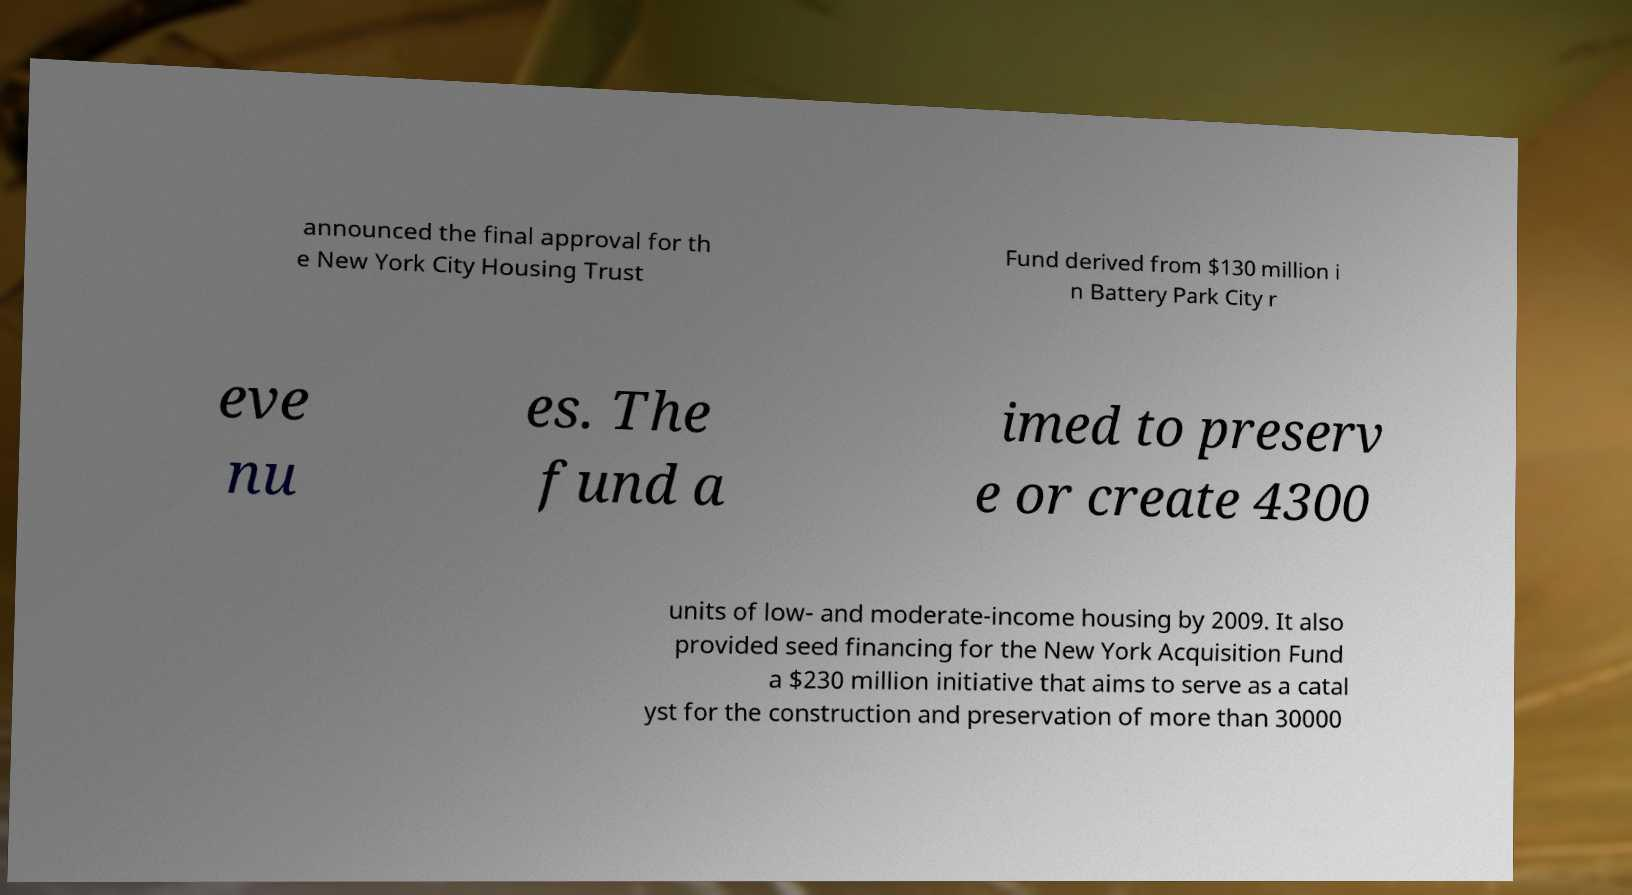I need the written content from this picture converted into text. Can you do that? announced the final approval for th e New York City Housing Trust Fund derived from $130 million i n Battery Park City r eve nu es. The fund a imed to preserv e or create 4300 units of low- and moderate-income housing by 2009. It also provided seed financing for the New York Acquisition Fund a $230 million initiative that aims to serve as a catal yst for the construction and preservation of more than 30000 